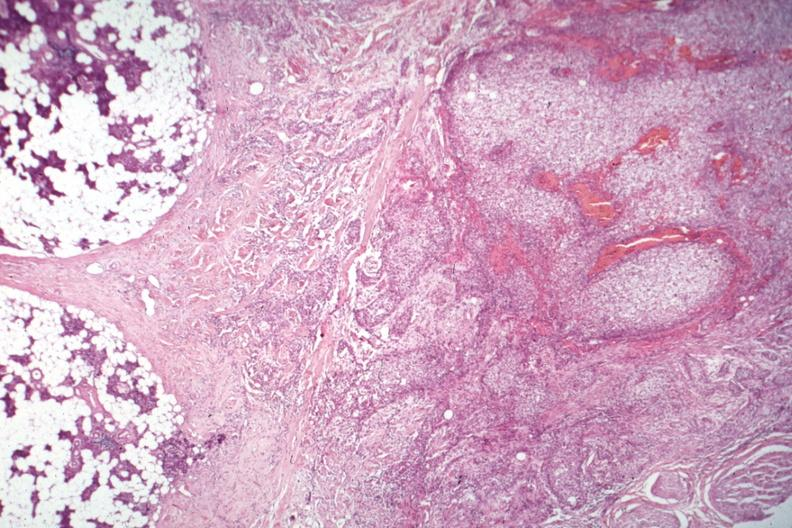s endocrine present?
Answer the question using a single word or phrase. Yes 